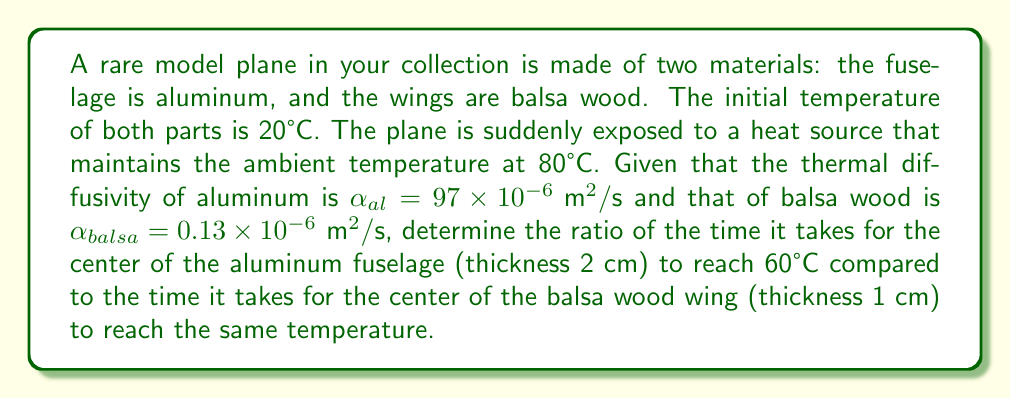Give your solution to this math problem. To solve this problem, we'll use the solution to the one-dimensional heat equation for a plane wall with constant surface temperatures:

$$\frac{T(x,t) - T_s}{T_i - T_s} = \sum_{n=1}^{\infty} \frac{4}{\pi(2n-1)} \sin\left(\frac{(2n-1)\pi x}{2L}\right) e^{-\alpha\left(\frac{(2n-1)\pi}{2L}\right)^2 t}$$

Where $T(x,t)$ is the temperature at position $x$ and time $t$, $T_s$ is the surface temperature, $T_i$ is the initial temperature, $L$ is the half-thickness, and $\alpha$ is the thermal diffusivity.

For the center of the material ($x = 0$), this simplifies to:

$$\frac{T(0,t) - T_s}{T_i - T_s} = \frac{4}{\pi} \sum_{n=1}^{\infty} \frac{(-1)^{n+1}}{2n-1} e^{-\alpha\left(\frac{(2n-1)\pi}{2L}\right)^2 t}$$

We're interested in the time when $T(0,t) = 60°C$. Let's solve this for each material:

1) For aluminum:
   $T_i = 20°C$, $T_s = 80°C$, $L = 0.01 \text{ m}$
   
   $$\frac{60 - 80}{20 - 80} = \frac{4}{\pi} \sum_{n=1}^{\infty} \frac{(-1)^{n+1}}{2n-1} e^{-97 \times 10^{-6}\left(\frac{(2n-1)\pi}{0.02}\right)^2 t_{al}}$$

2) For balsa wood:
   $T_i = 20°C$, $T_s = 80°C$, $L = 0.005 \text{ m}$
   
   $$\frac{60 - 80}{20 - 80} = \frac{4}{\pi} \sum_{n=1}^{\infty} \frac{(-1)^{n+1}}{2n-1} e^{-0.13 \times 10^{-6}\left(\frac{(2n-1)\pi}{0.01}\right)^2 t_{balsa}}$$

The left side of both equations is equal to $-1/3$. We can't solve these equations analytically, but we can use the fact that the solutions will have the same form:

$$t_{al} = \frac{0.02^2}{97 \times 10^{-6}} \cdot C = 4123.7 \cdot C$$
$$t_{balsa} = \frac{0.01^2}{0.13 \times 10^{-6}} \cdot C = 769230.8 \cdot C$$

Where $C$ is some constant that's the same for both materials.

The ratio of these times is:

$$\frac{t_{al}}{t_{balsa}} = \frac{4123.7}{769230.8} \approx 0.00536$$
Answer: $\frac{t_{al}}{t_{balsa}} \approx 0.00536$ 